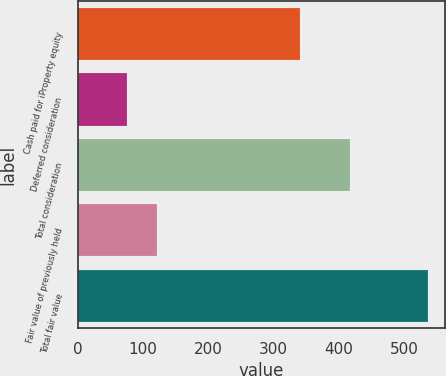Convert chart. <chart><loc_0><loc_0><loc_500><loc_500><bar_chart><fcel>Cash paid for iProperty equity<fcel>Deferred consideration<fcel>Total consideration<fcel>Fair value of previously held<fcel>Total fair value<nl><fcel>340<fcel>76<fcel>416<fcel>122<fcel>536<nl></chart> 